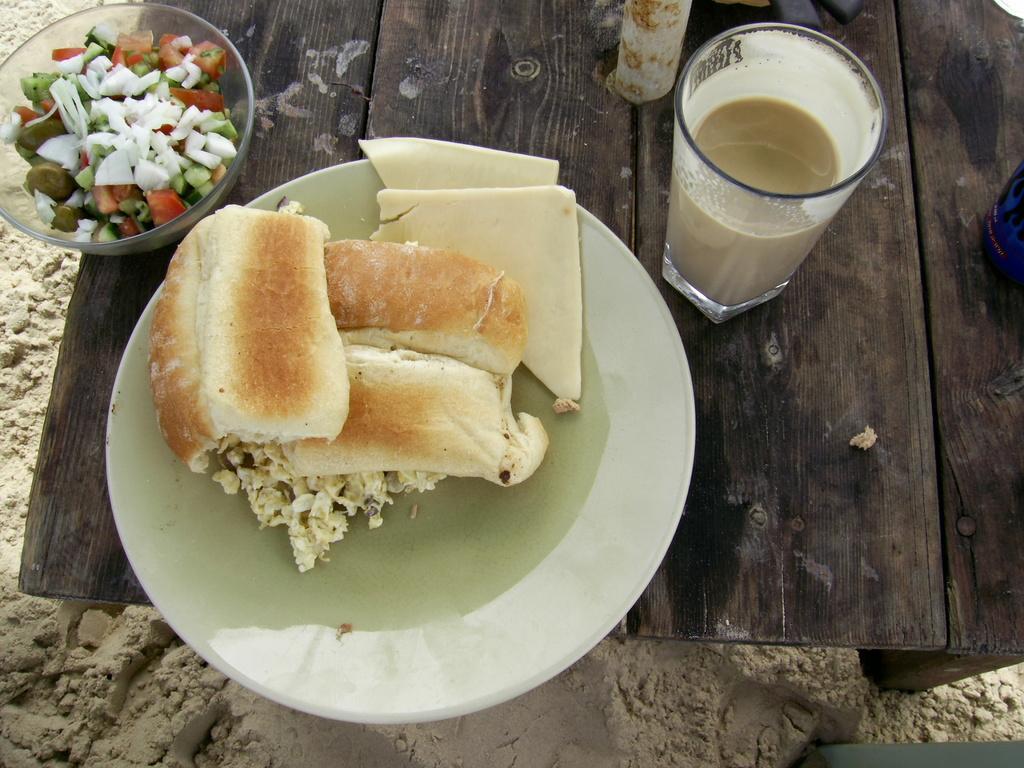How would you summarize this image in a sentence or two? In the image in the center, we can see one table. On the table, we can see one plate, bowl and glass. In the plate and bowl, we can see food items. In the glass we can see coffee. 